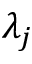Convert formula to latex. <formula><loc_0><loc_0><loc_500><loc_500>\lambda _ { j }</formula> 